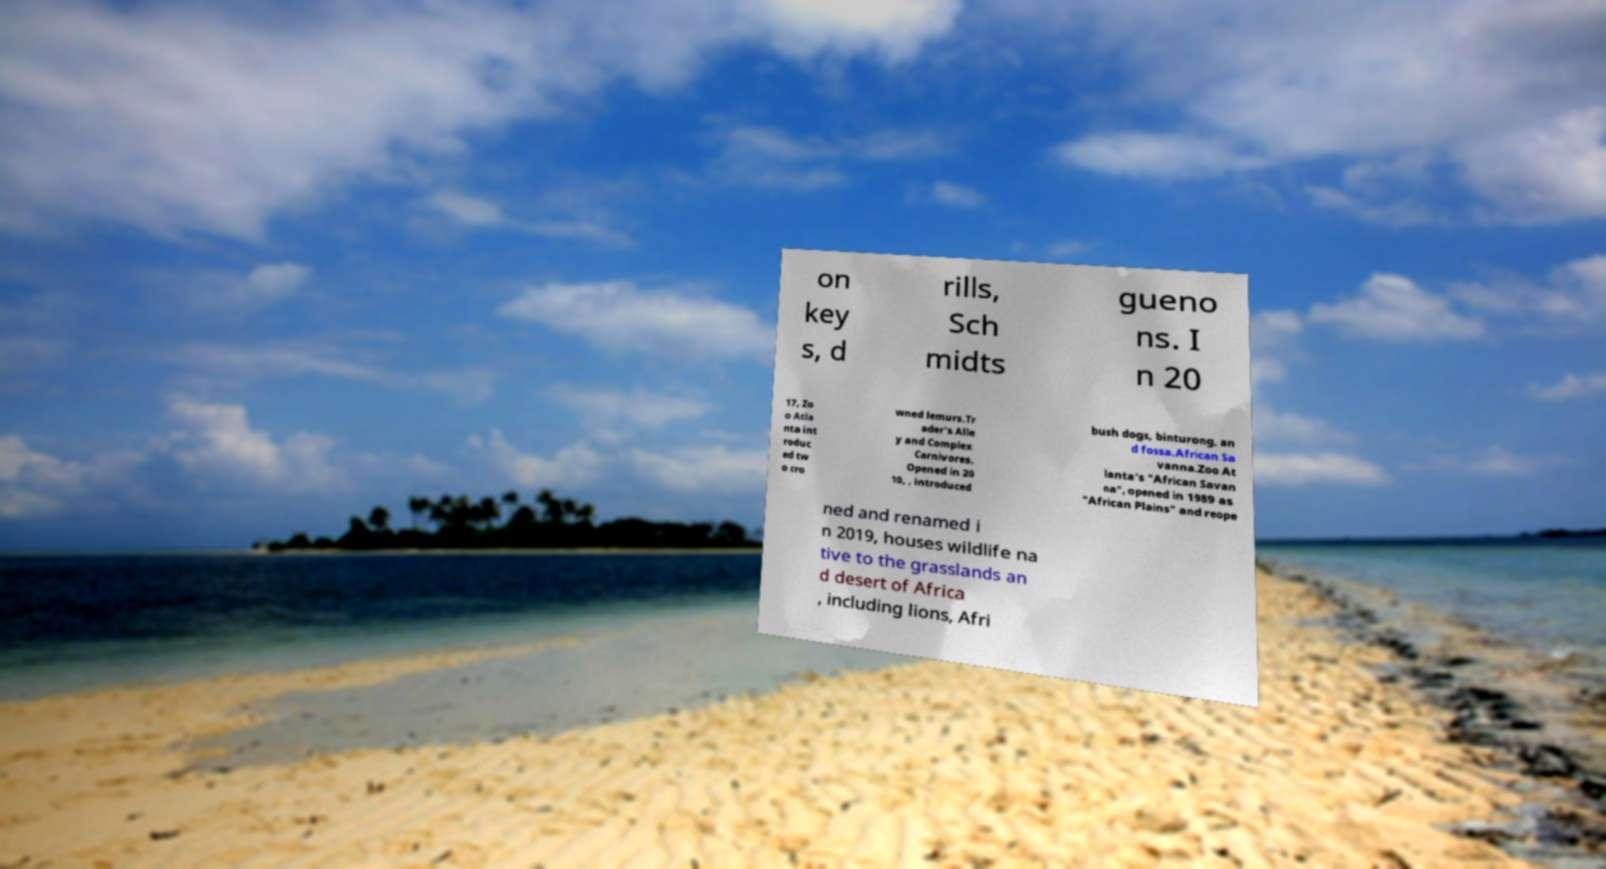What messages or text are displayed in this image? I need them in a readable, typed format. on key s, d rills, Sch midts gueno ns. I n 20 17, Zo o Atla nta int roduc ed tw o cro wned lemurs.Tr ader's Alle y and Complex Carnivores. Opened in 20 10, , introduced bush dogs, binturong, an d fossa.African Sa vanna.Zoo At lanta’s "African Savan na", opened in 1989 as "African Plains" and reope ned and renamed i n 2019, houses wildlife na tive to the grasslands an d desert of Africa , including lions, Afri 